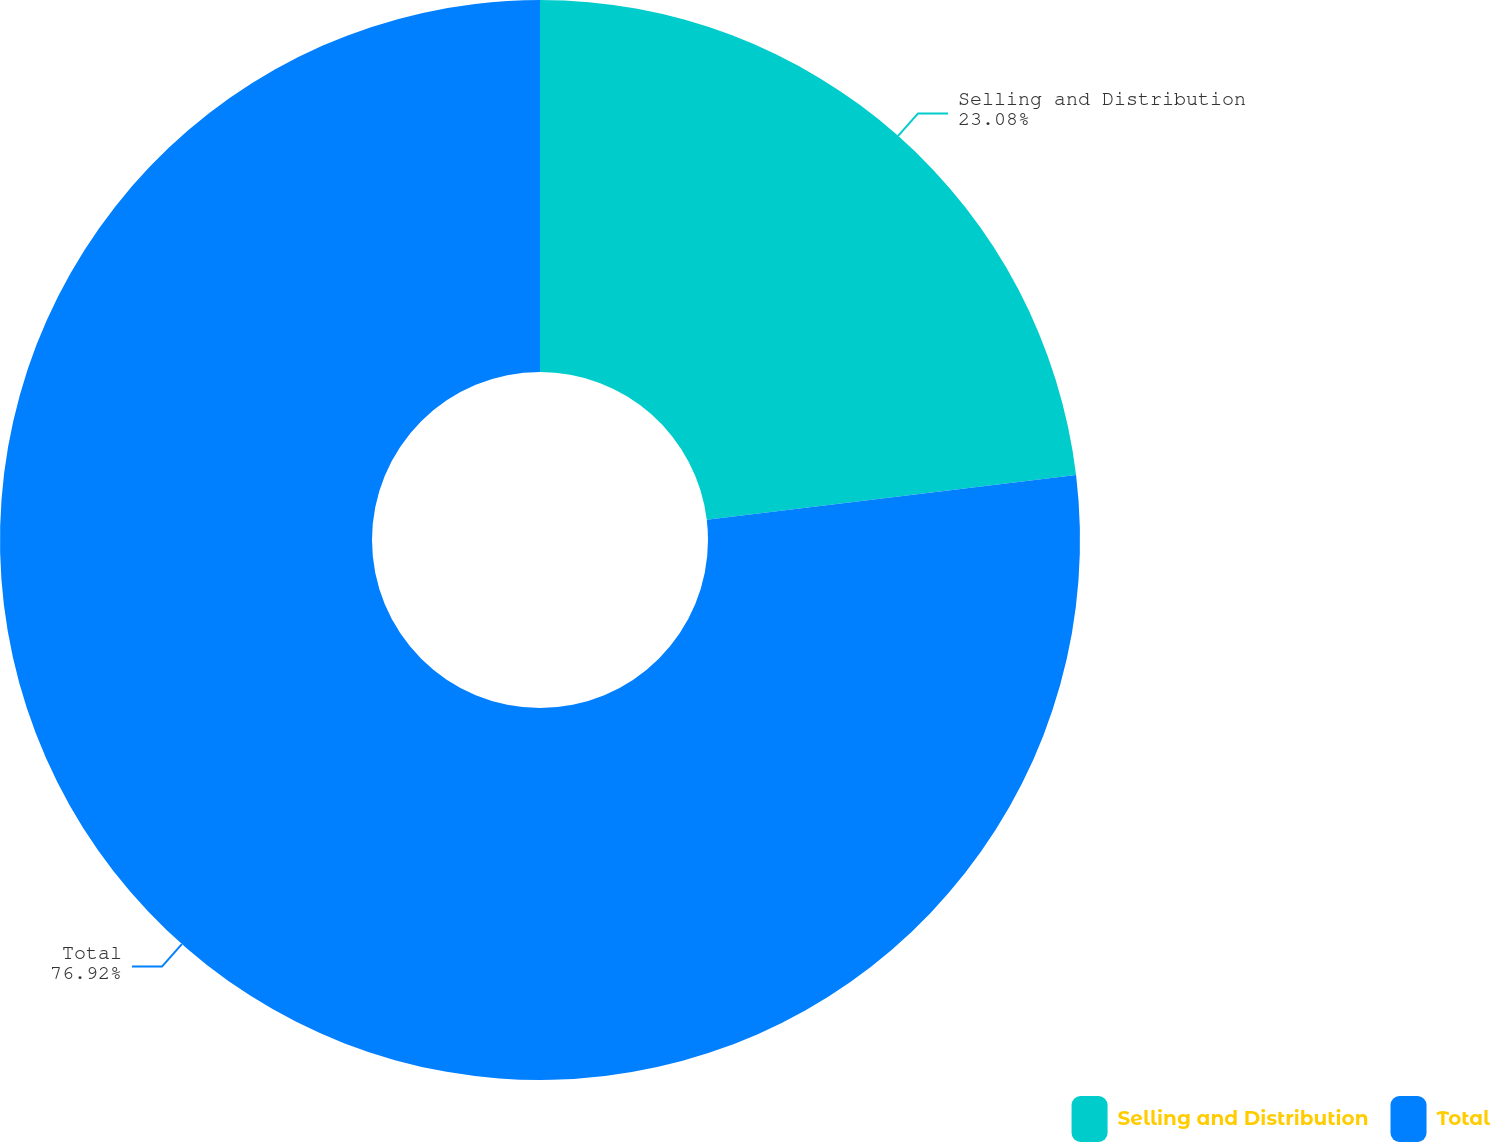<chart> <loc_0><loc_0><loc_500><loc_500><pie_chart><fcel>Selling and Distribution<fcel>Total<nl><fcel>23.08%<fcel>76.92%<nl></chart> 